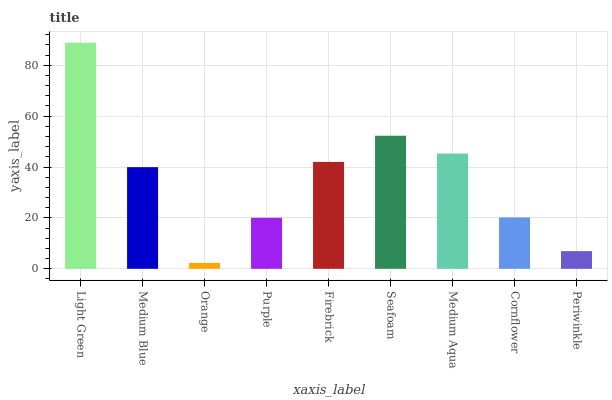Is Orange the minimum?
Answer yes or no. Yes. Is Light Green the maximum?
Answer yes or no. Yes. Is Medium Blue the minimum?
Answer yes or no. No. Is Medium Blue the maximum?
Answer yes or no. No. Is Light Green greater than Medium Blue?
Answer yes or no. Yes. Is Medium Blue less than Light Green?
Answer yes or no. Yes. Is Medium Blue greater than Light Green?
Answer yes or no. No. Is Light Green less than Medium Blue?
Answer yes or no. No. Is Medium Blue the high median?
Answer yes or no. Yes. Is Medium Blue the low median?
Answer yes or no. Yes. Is Periwinkle the high median?
Answer yes or no. No. Is Orange the low median?
Answer yes or no. No. 